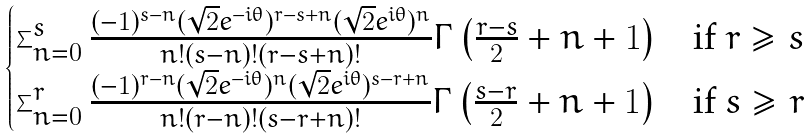<formula> <loc_0><loc_0><loc_500><loc_500>\begin{cases} \sum _ { n = 0 } ^ { s } \frac { ( - 1 ) ^ { s - n } ( \sqrt { 2 } e ^ { - i \theta } ) ^ { r - s + n } ( \sqrt { 2 } e ^ { i \theta } ) ^ { n } } { n ! ( s - n ) ! ( r - s + n ) ! } \Gamma \left ( \frac { r - s } { 2 } + n + 1 \right ) & \text {if $r \geq s$} \\ \sum _ { n = 0 } ^ { r } \frac { ( - 1 ) ^ { r - n } ( \sqrt { 2 } e ^ { - i \theta } ) ^ { n } ( \sqrt { 2 } e ^ { i \theta } ) ^ { s - r + n } } { n ! ( r - n ) ! ( s - r + n ) ! } \Gamma \left ( \frac { s - r } { 2 } + n + 1 \right ) & \text {if $s \geq r$} \end{cases}</formula> 